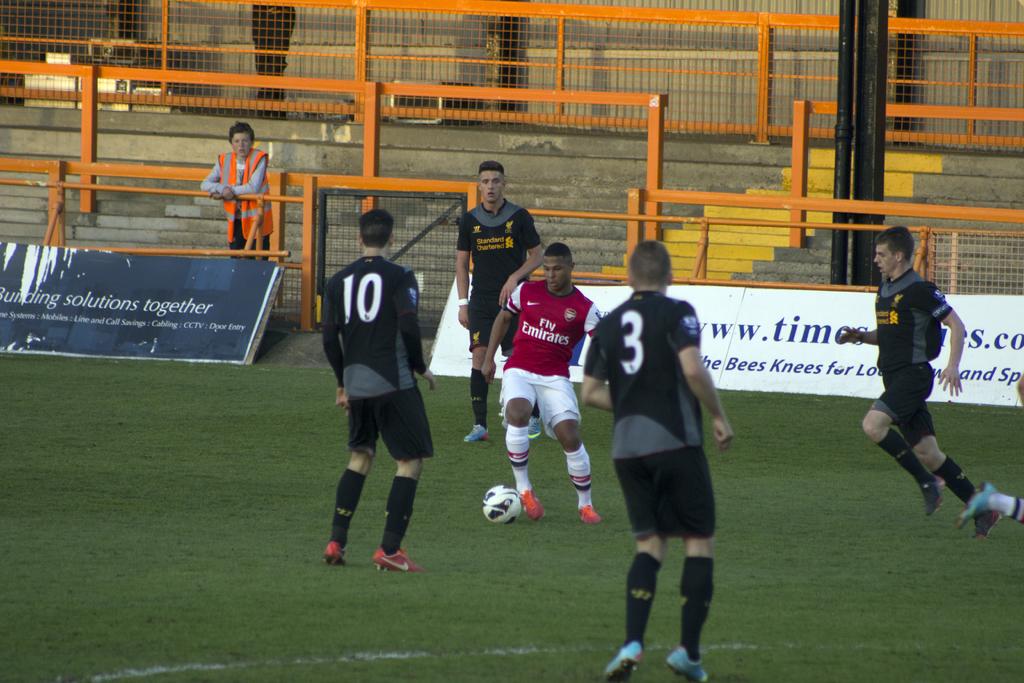What is the jersey number on the right?
Make the answer very short. 3. What is the jersey number on the left?
Give a very brief answer. 10. 